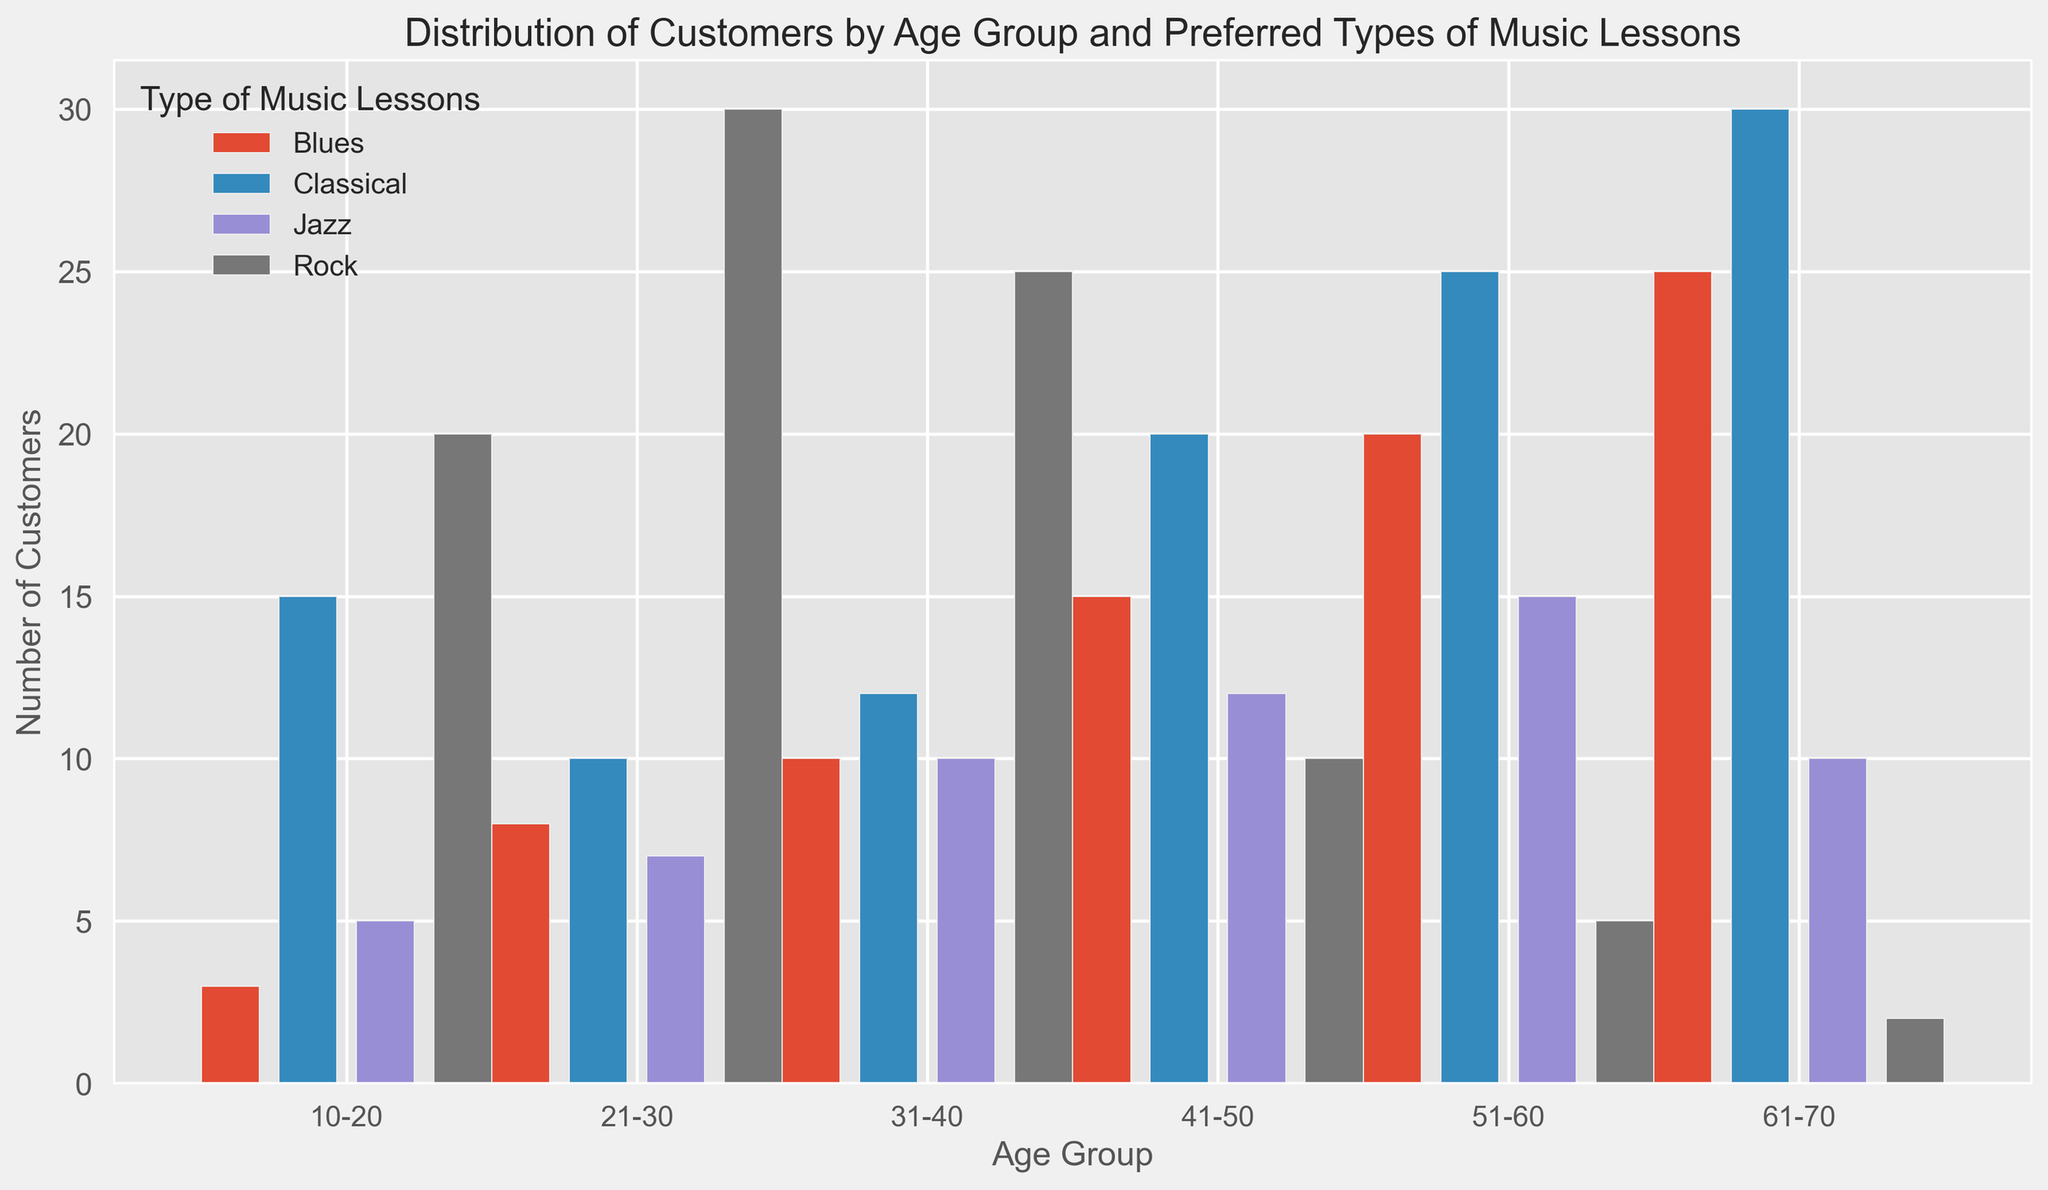Which age group prefers Classical music the most? To determine which age group prefers Classical music the most, we look at the bars corresponding to Classical music across all age groups. The highest bar is in the '61-70' age group.
Answer: 61-70 How many customers aged 21-30 prefer either Rock or Blues lessons? We look at the 21-30 age group's Rock and Blues bars and add their heights. For Rock, it's 30, and for Blues, it's 8. Thus, 30 + 8 = 38 customers.
Answer: 38 Which type of music lesson is the least preferred by customers aged 10-20? We examine the bars for the 10-20 age group. The shortest bar corresponds to Blues, which is at 3.
Answer: Blues Compare the number of customers aged 31-40 taking Jazz lessons with those aged 41-50 taking Rock lessons. Which is greater? For 31-40 Jazz lessons, the bar height is 10. For 41-50 Rock lessons, it’s 10. Both have the same preference for these lessons.
Answer: Equal What is the total number of customers who prefer Rock music across all age groups? Adding the heights of Rock bars: 20 (10-20) + 30 (21-30) + 25 (31-40) + 10 (41-50) + 5 (51-60) + 2 (61-70) = 92.
Answer: 92 Which type of music lesson is preferred by customers aged 51-60 the most? In the 51-60 age group, the highest bar is for Classical music at 25.
Answer: Classical What’s the average number of customers aged 31-40 taking either Classical or Jazz lessons? The number of customers is 12 for Classical and 10 for Jazz. The average is (12 + 10) / 2 = 11.
Answer: 11 If we combine the customers for Blues and Jazz lessons, which age group has the highest total? For each age group, we sum Blues and Jazz customers and find the highest:
- 10-20: 3 (Blues) + 5 (Jazz) = 8
- 21-30: 8 (Blues) + 7 (Jazz) = 15
- 31-40: 10 (Blues) + 10 (Jazz) = 20
- 41-50: 15 (Blues) + 12 (Jazz) = 27
- 51-60: 20 (Blues) + 15 (Jazz) = 35
- 61-70: 25 (Blues) + 10 (Jazz) = 35
The highest totals are in the 51-60 and 61-70 age groups.
Answer: 51-60 and 61-70 